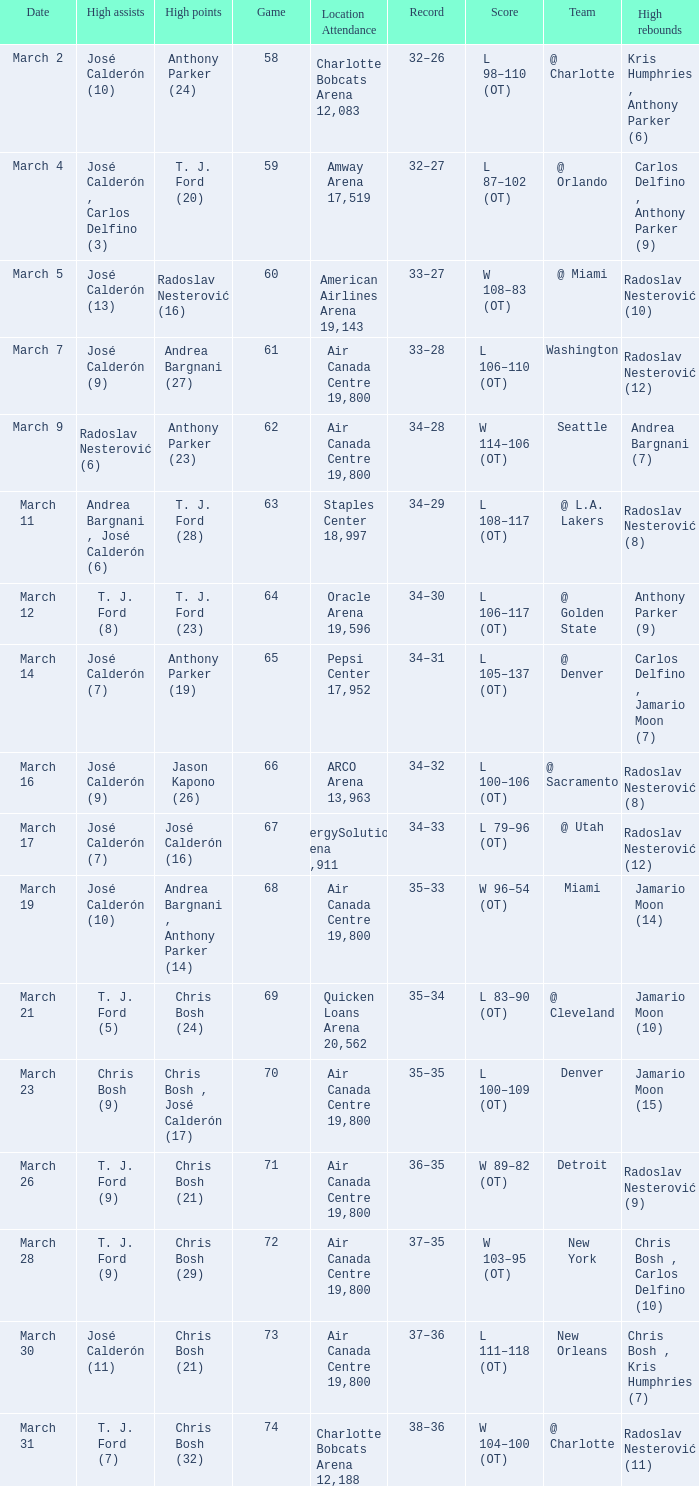What numbered game featured a High rebounds of radoslav nesterović (8), and a High assists of josé calderón (9)? 1.0. 